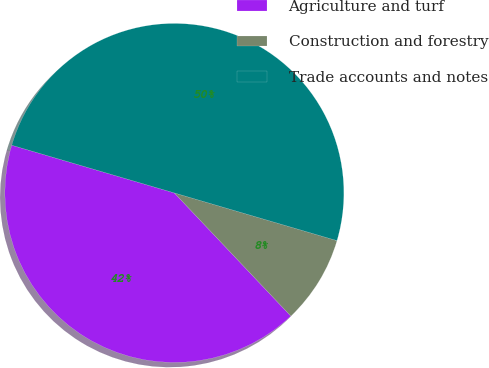<chart> <loc_0><loc_0><loc_500><loc_500><pie_chart><fcel>Agriculture and turf<fcel>Construction and forestry<fcel>Trade accounts and notes<nl><fcel>41.6%<fcel>8.4%<fcel>50.0%<nl></chart> 